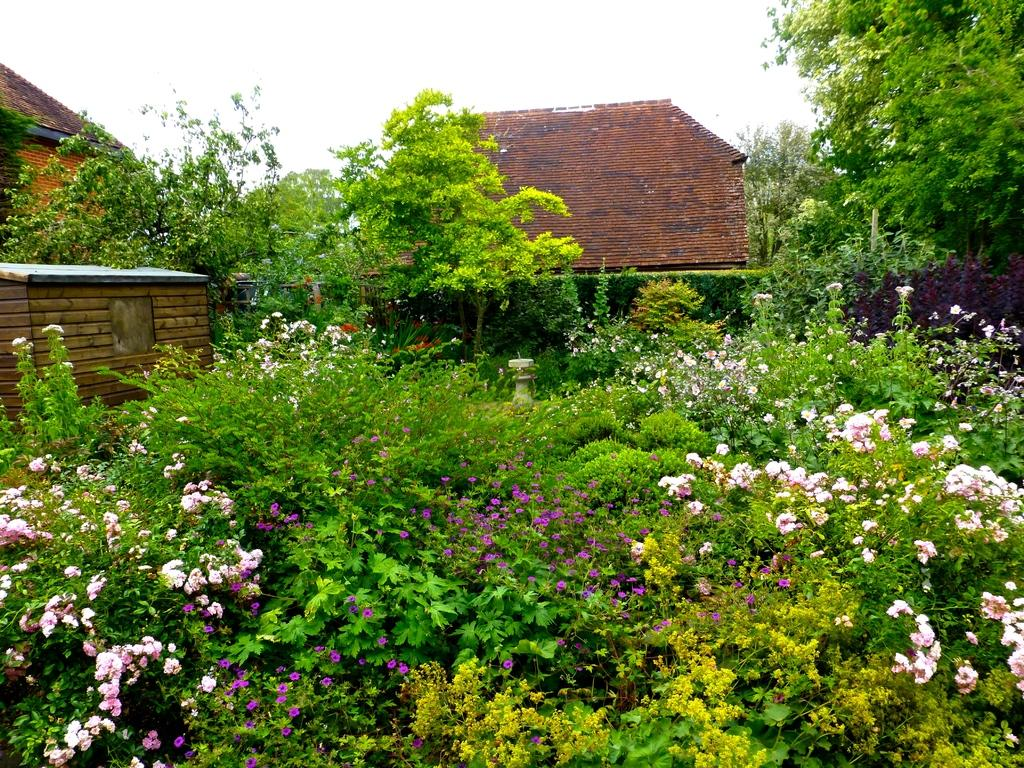What type of plants can be seen in the front portion of the image? There are flower plants in the front portion of the image. What is visible at the top of the image? The sky is visible at the top of the image. What type of structures are present in the image? There are houses in the image. What other natural elements can be seen in the image? Trees are present in the image. Can you tell me what type of hat is being worn by the tree in the image? There are no hats present in the image, as trees do not wear hats. What verse can be recited while observing the railway in the image? There is no railway present in the image, so there is no verse to recite. 